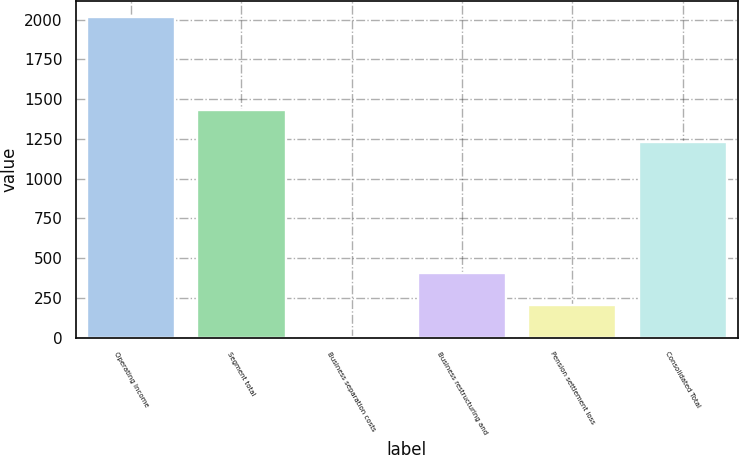<chart> <loc_0><loc_0><loc_500><loc_500><bar_chart><fcel>Operating Income<fcel>Segment total<fcel>Business separation costs<fcel>Business restructuring and<fcel>Pension settlement loss<fcel>Consolidated Total<nl><fcel>2015<fcel>1433.95<fcel>7.5<fcel>409<fcel>208.25<fcel>1233.2<nl></chart> 